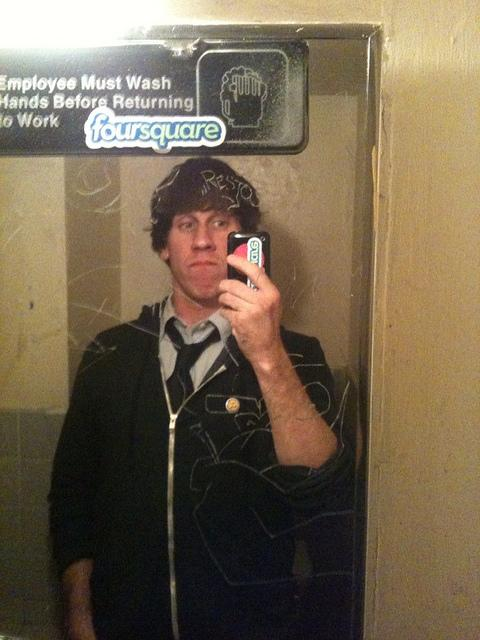Who took the photo of this man? himself 